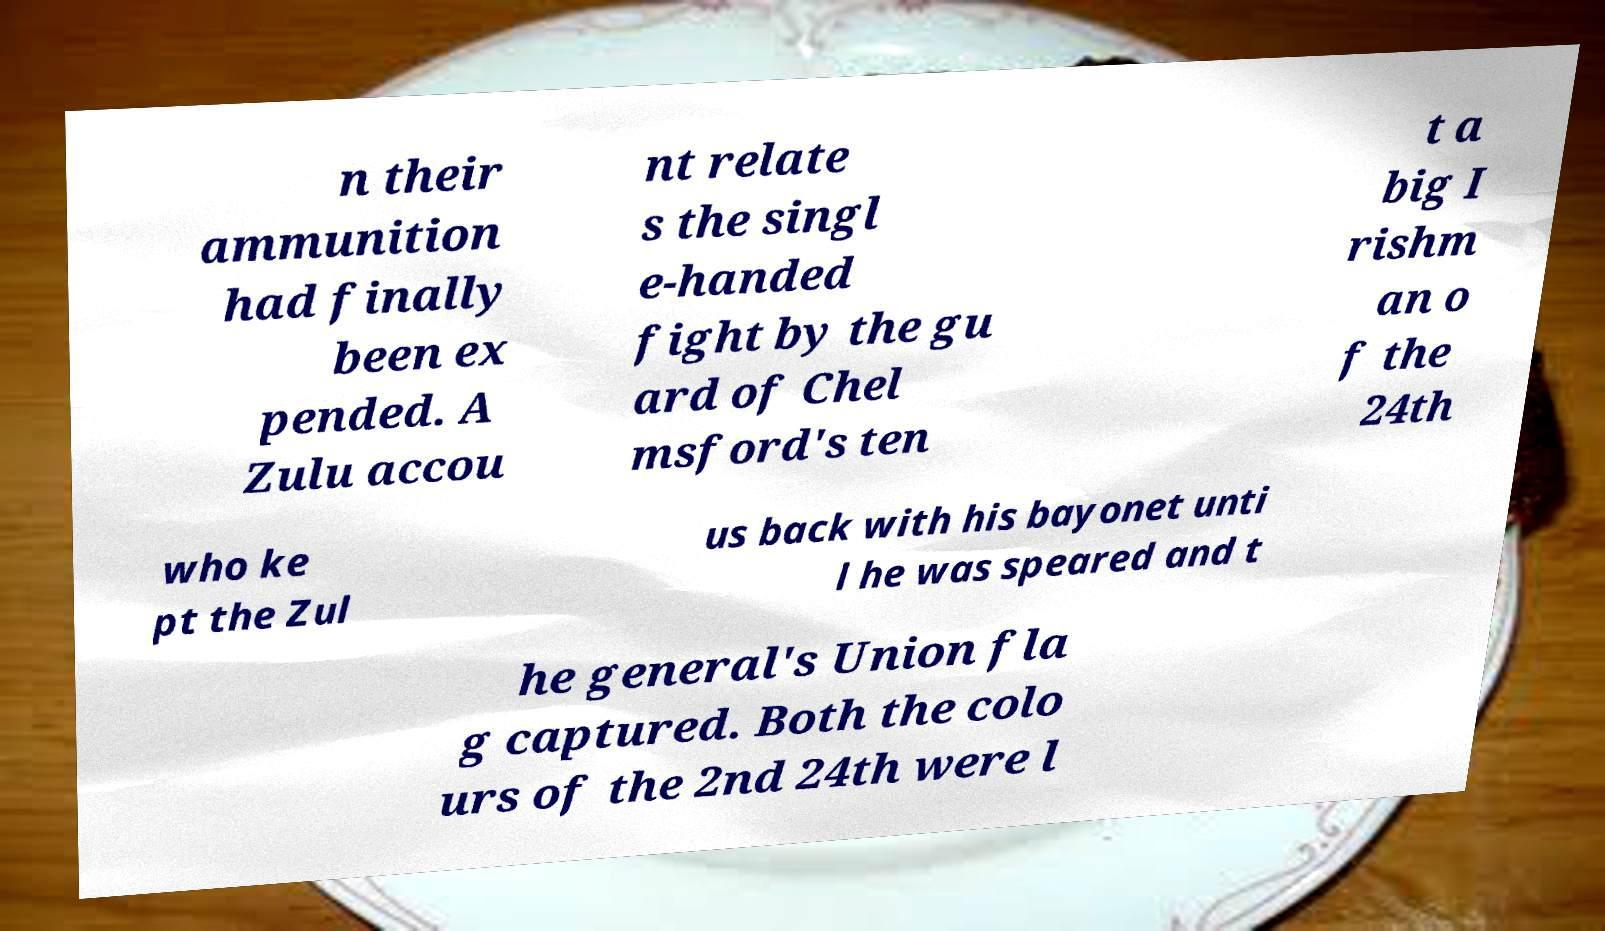Can you read and provide the text displayed in the image?This photo seems to have some interesting text. Can you extract and type it out for me? n their ammunition had finally been ex pended. A Zulu accou nt relate s the singl e-handed fight by the gu ard of Chel msford's ten t a big I rishm an o f the 24th who ke pt the Zul us back with his bayonet unti l he was speared and t he general's Union fla g captured. Both the colo urs of the 2nd 24th were l 